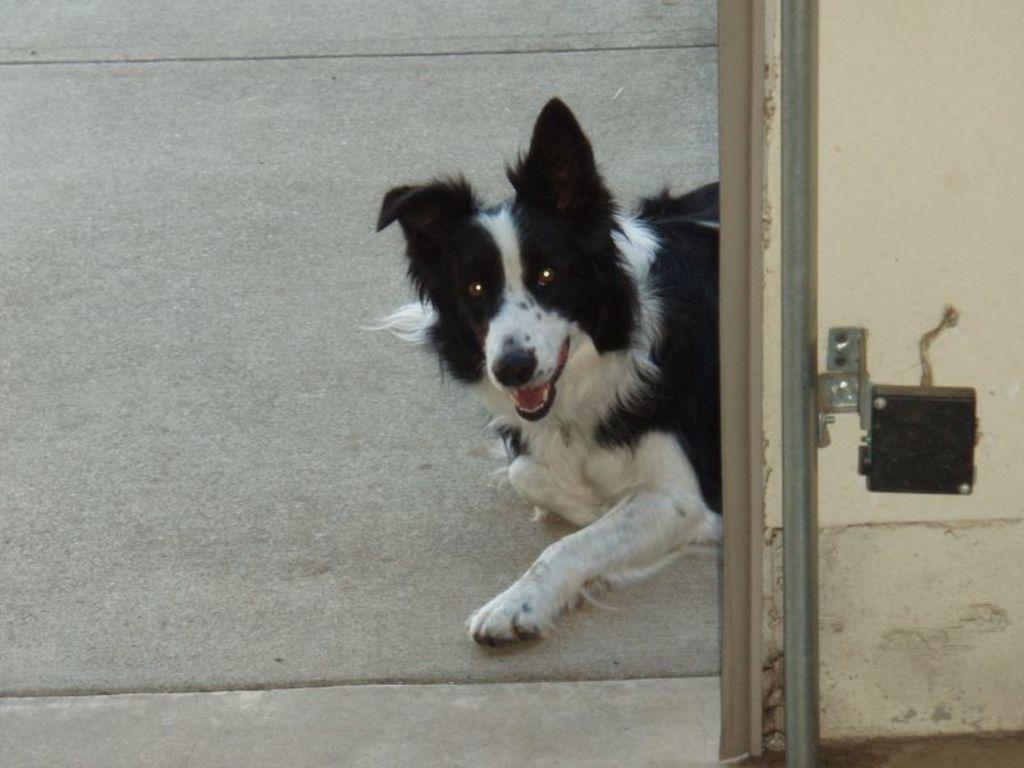What type of animal is present on the surface in the image? There is a dog on the surface in the image. What can be seen on the wall in the image? There is a rod and a device on the wall in the image. What type of lipstick is the dog wearing in the image? There is no lipstick or any indication of the dog wearing lipstick in the image. 